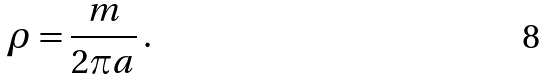<formula> <loc_0><loc_0><loc_500><loc_500>\rho = \frac { m } { 2 \pi a } \, .</formula> 